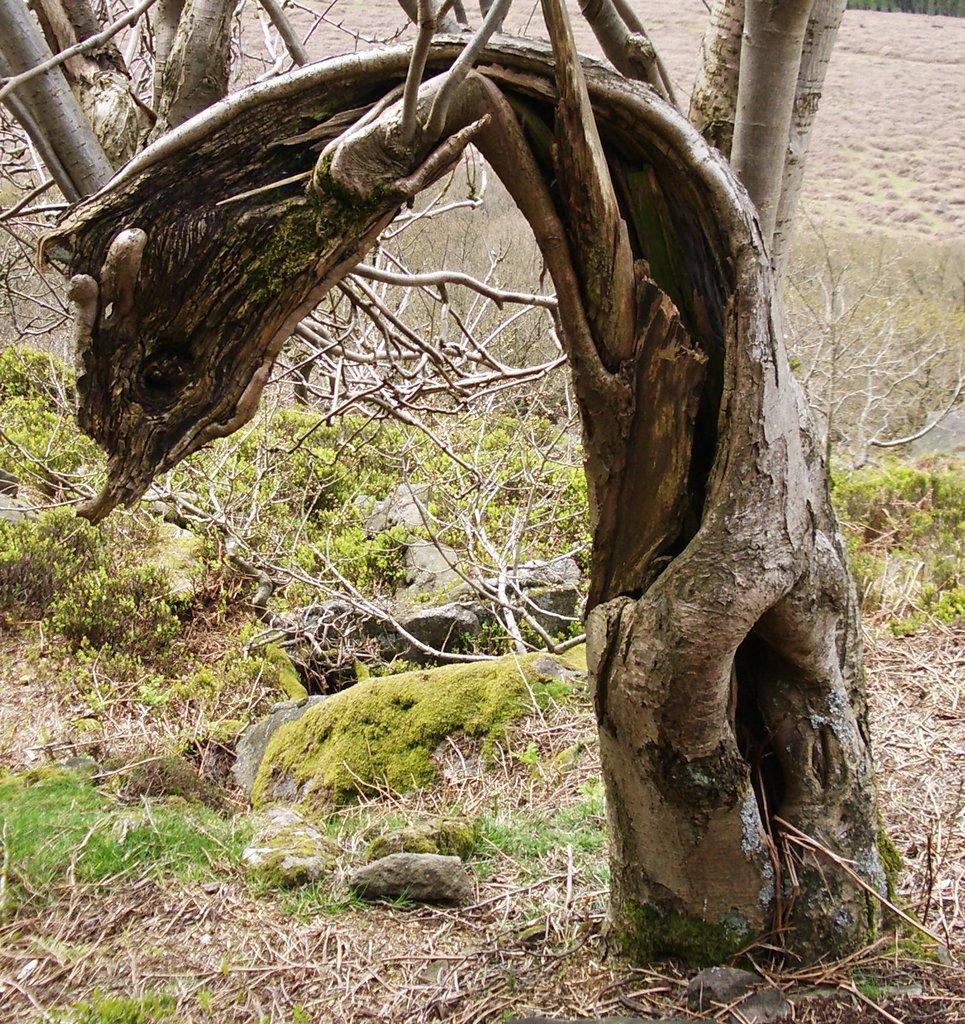In one or two sentences, can you explain what this image depicts? On the right side, there is a tree, grass and stones on the ground. In the background, there are trees and there is dry land. 